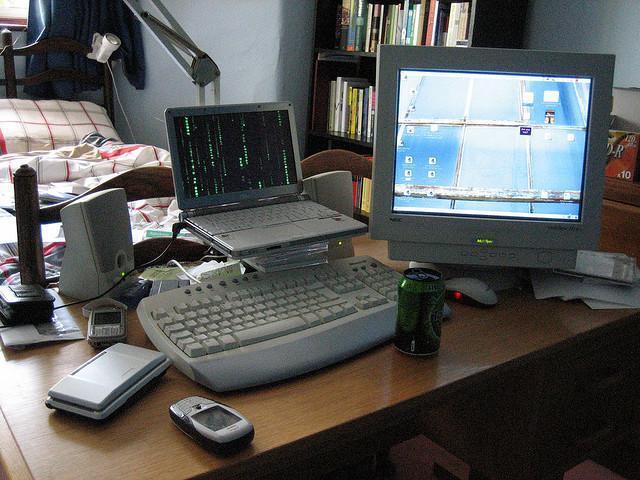How many cell phones are on the desk?
Give a very brief answer. 2. How many screens are in the image?
Give a very brief answer. 2. How many beds are there?
Give a very brief answer. 1. How many keyboards are there?
Give a very brief answer. 2. 